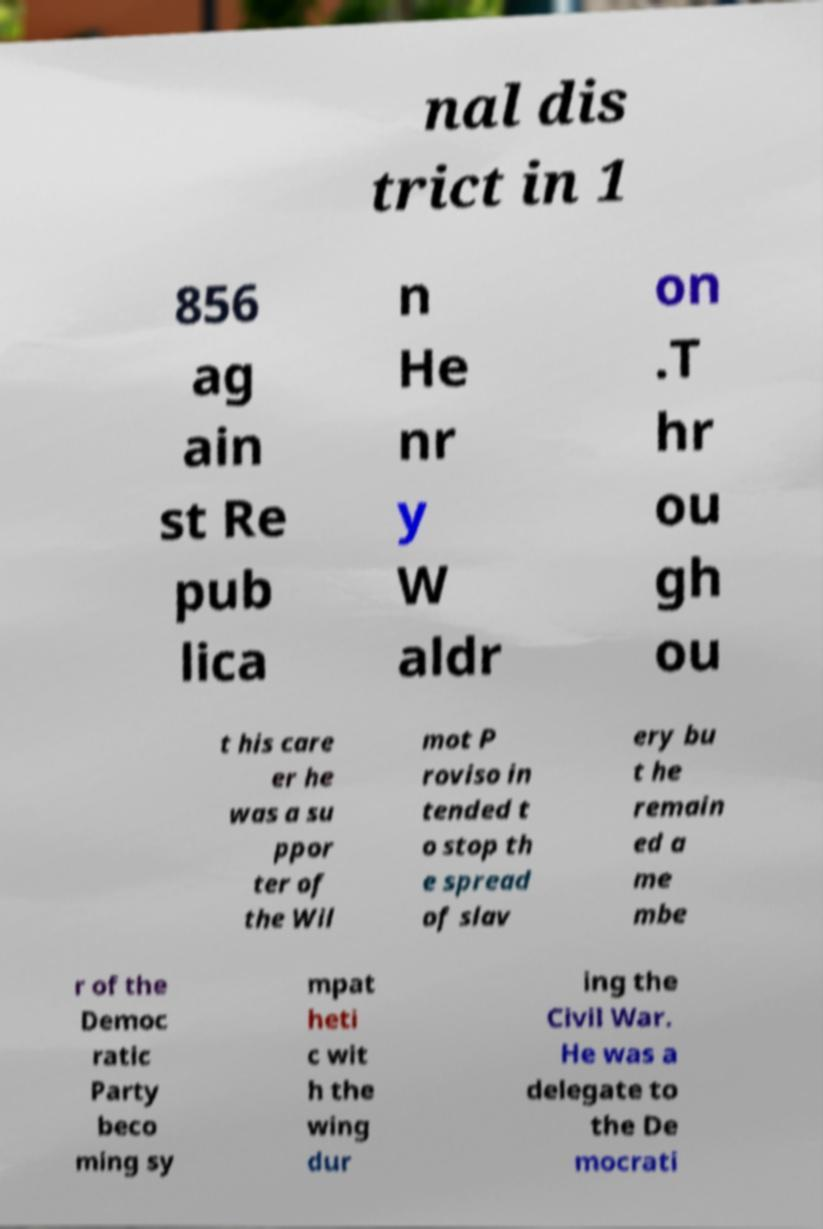Can you accurately transcribe the text from the provided image for me? nal dis trict in 1 856 ag ain st Re pub lica n He nr y W aldr on .T hr ou gh ou t his care er he was a su ppor ter of the Wil mot P roviso in tended t o stop th e spread of slav ery bu t he remain ed a me mbe r of the Democ ratic Party beco ming sy mpat heti c wit h the wing dur ing the Civil War. He was a delegate to the De mocrati 